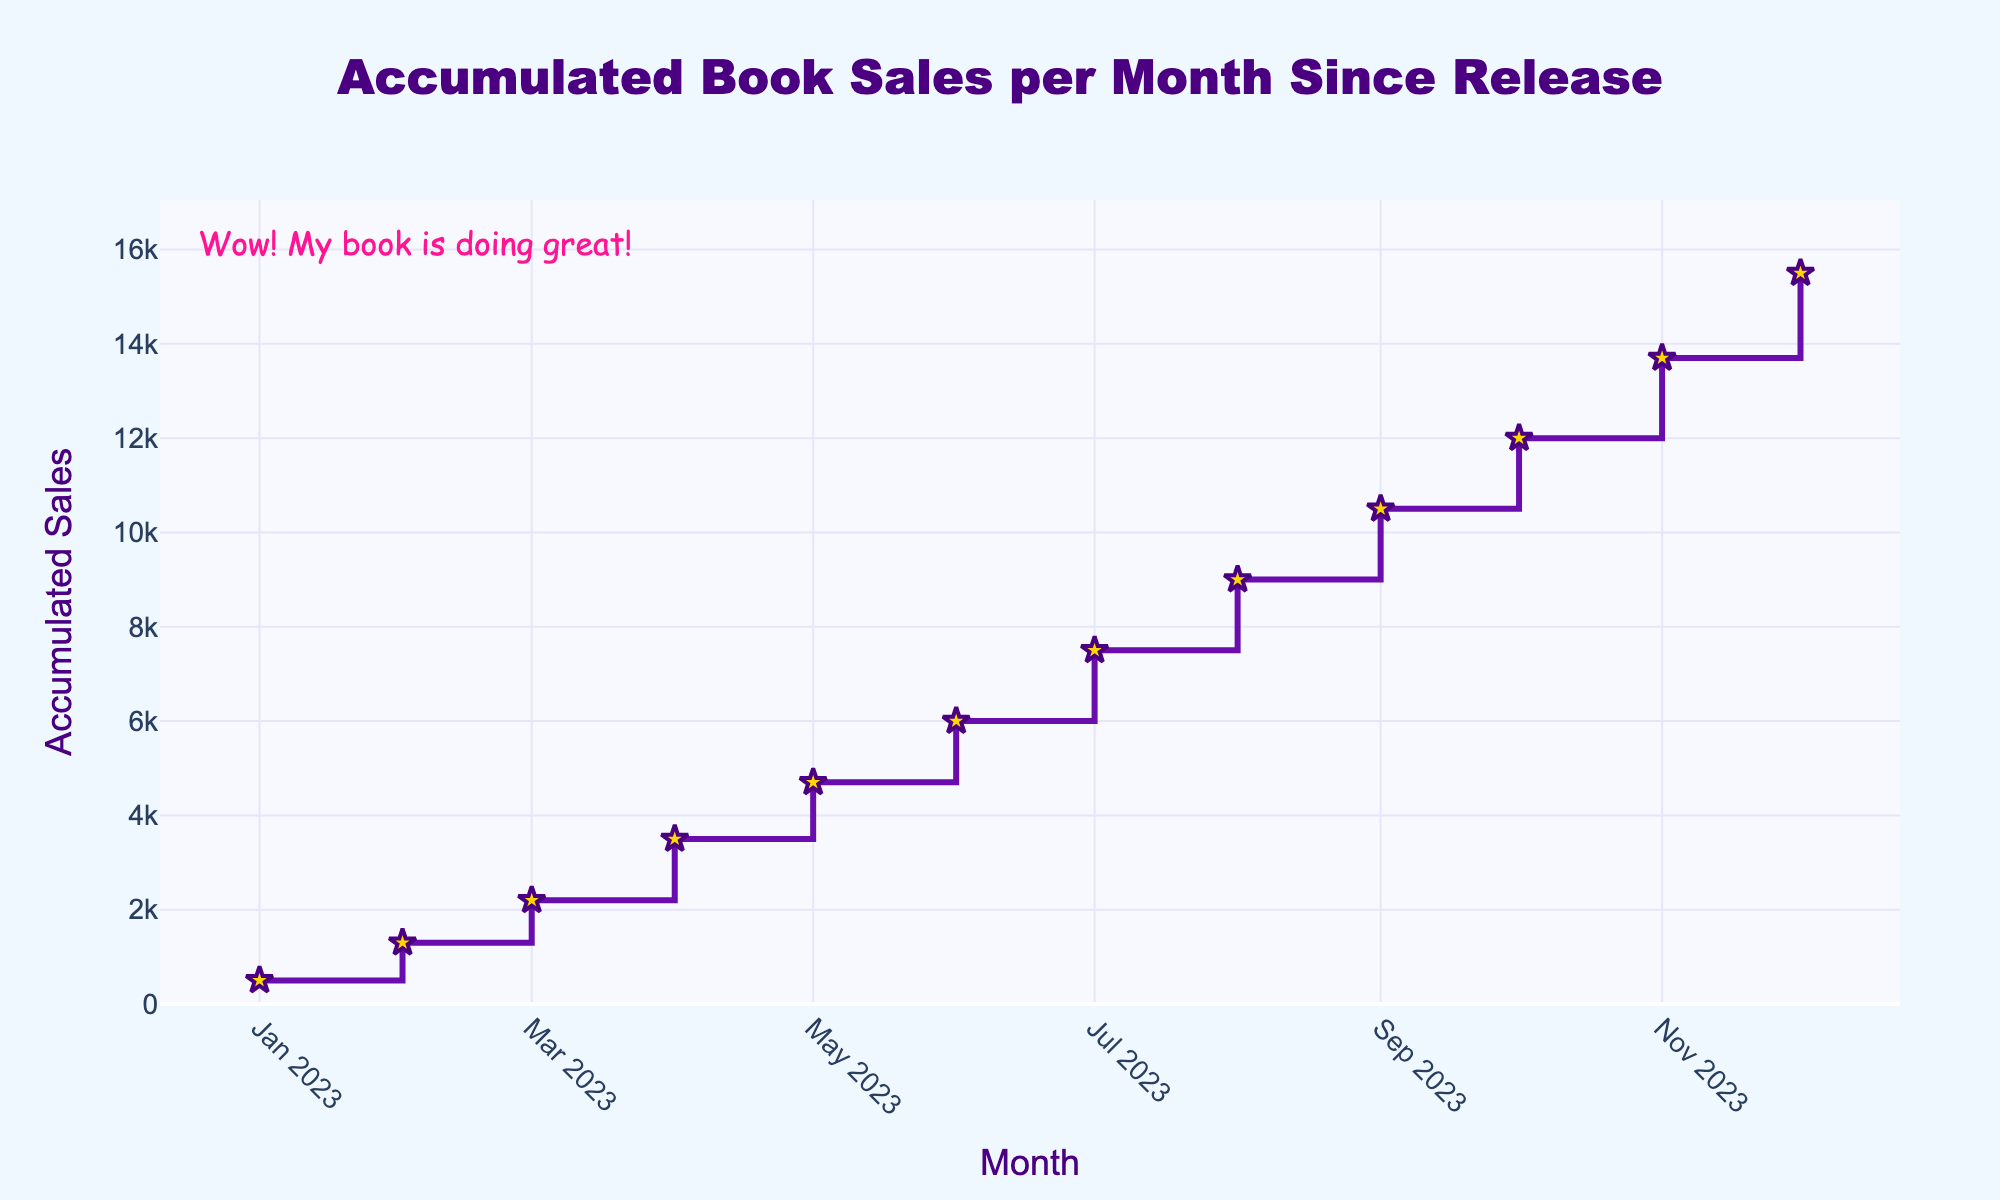What is the title of the plot? The title is displayed at the top center of the plot.
Answer: Accumulated Book Sales per Month Since Release How many data points are shown on the plot? Count the markers representing data points on the plot. There is one marker for each month.
Answer: 12 Which month shows the highest increase in accumulated book sales? Compare the vertical steps between consecutive months to find the largest increase. The step from March to April has the largest vertical jump.
Answer: April 2023 What are the accumulated book sales by June 2023? Locate the data point corresponding to June 2023 on the x-axis and read the y-axis value.
Answer: 6000 How does the accumulated sales for August 2023 compare to July 2023? Check the y-axis values for August and July 2023 and subtract the July value from the August value.
Answer: 1500 more in August What is the average accumulated sales over the first six months? Sum the sales from January to June and divide by 6. (500 + 1300 + 2200 + 3500 + 4700 + 6000) / 6.
Answer: 3033.33 Which month had 7500 in accumulated book sales? Identify the month where the y-axis value aligns with 7500.
Answer: July 2023 What is the total increase in accumulated sales from January 2023 to December 2023? Subtract the sales in January 2023 from the sales in December 2023. 15500 - 500.
Answer: 15000 Is there any month where the increase in sales is less than 1000 units? Compare the vertical steps between each pair of consecutive months to identify any steps smaller than 1000 units. February to March is 2200 - 1300 = 900.
Answer: March 2023 What is the trend shown in the accumulated sales over the year? Observe the overall direction and shape of the plot line. The plot line consistently rises, indicating growing accumulated sales each month.
Answer: Increasing trend 